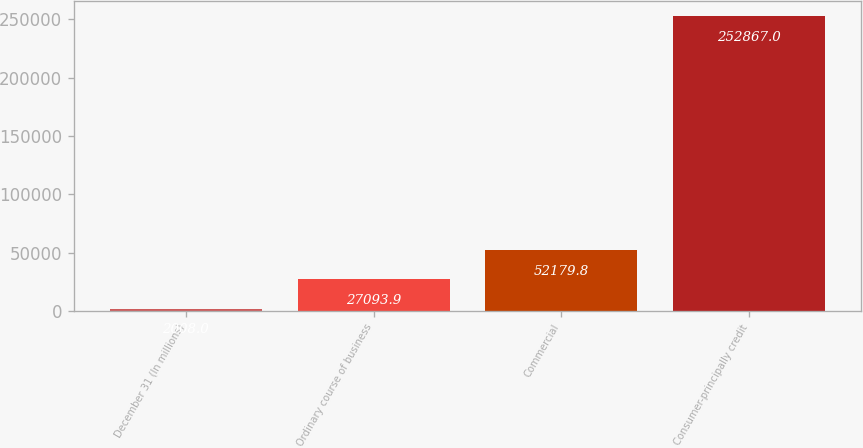<chart> <loc_0><loc_0><loc_500><loc_500><bar_chart><fcel>December 31 (In millions)<fcel>Ordinary course of business<fcel>Commercial<fcel>Consumer-principally credit<nl><fcel>2008<fcel>27093.9<fcel>52179.8<fcel>252867<nl></chart> 